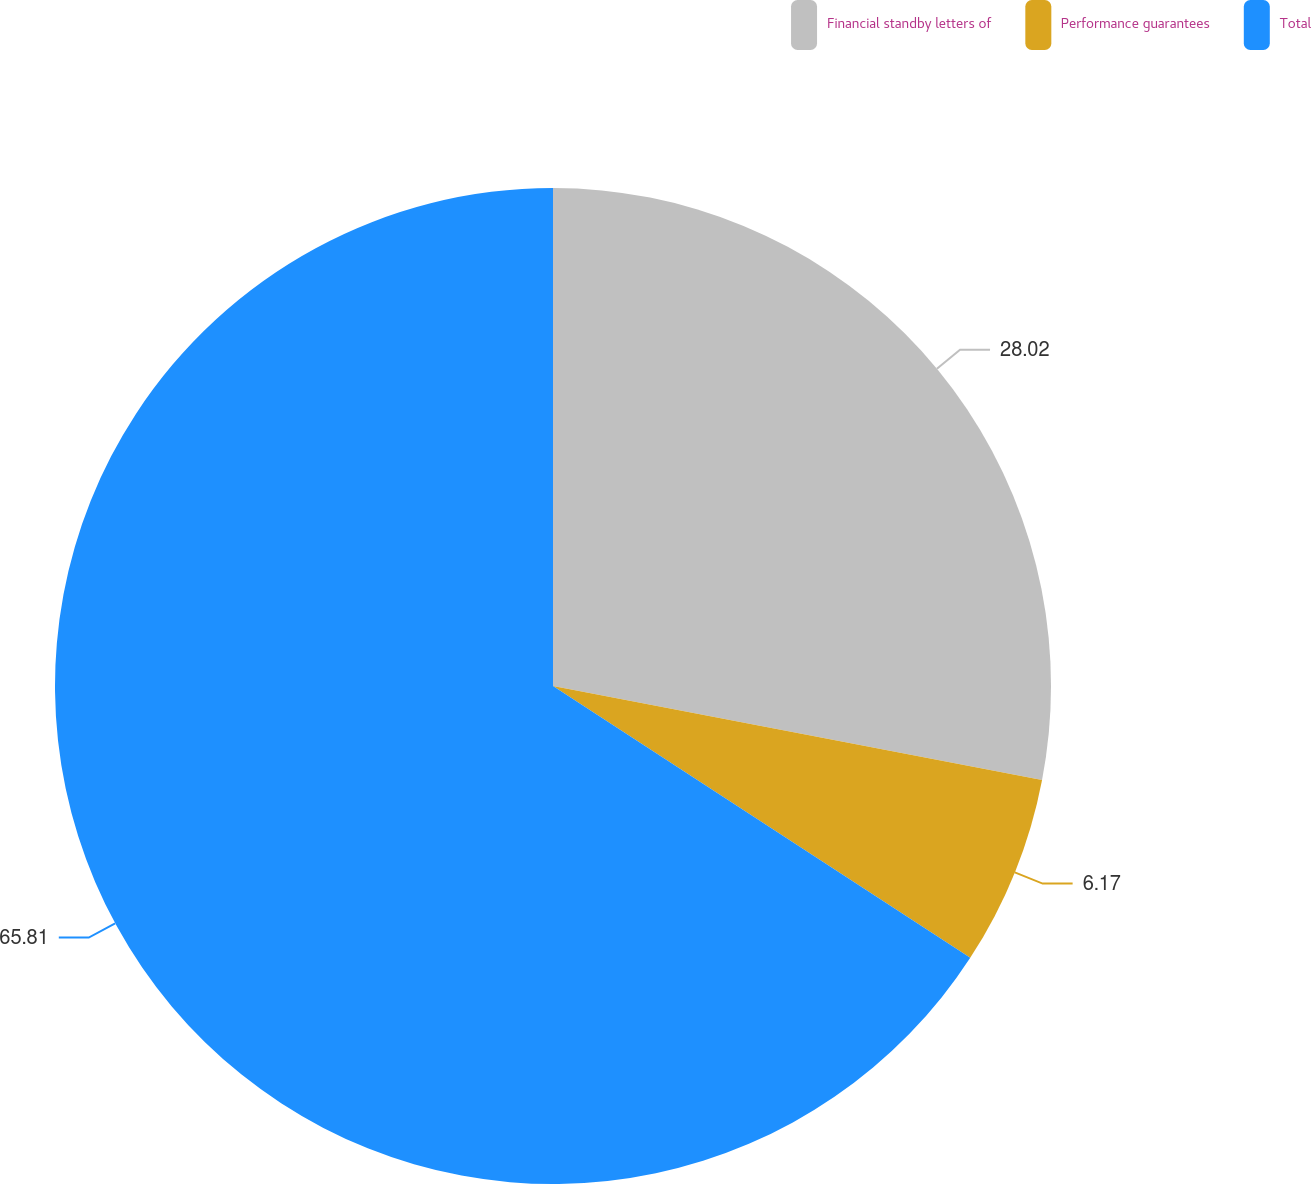Convert chart. <chart><loc_0><loc_0><loc_500><loc_500><pie_chart><fcel>Financial standby letters of<fcel>Performance guarantees<fcel>Total<nl><fcel>28.02%<fcel>6.17%<fcel>65.81%<nl></chart> 